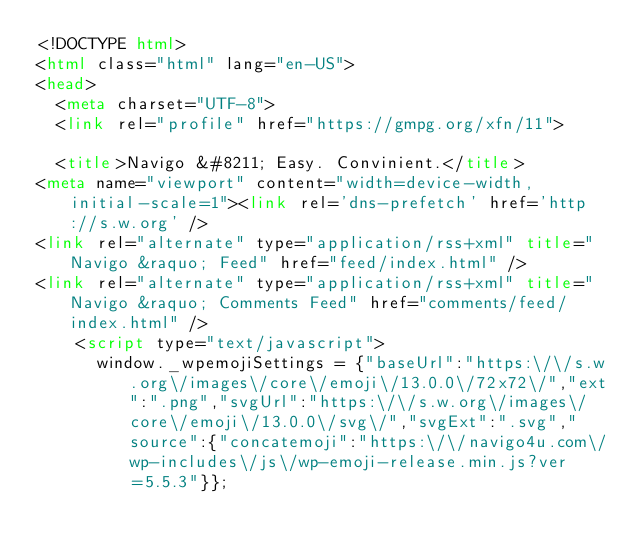Convert code to text. <code><loc_0><loc_0><loc_500><loc_500><_HTML_><!DOCTYPE html>
<html class="html" lang="en-US">
<head>
	<meta charset="UTF-8">
	<link rel="profile" href="https://gmpg.org/xfn/11">

	<title>Navigo &#8211; Easy. Convinient.</title>
<meta name="viewport" content="width=device-width, initial-scale=1"><link rel='dns-prefetch' href='http://s.w.org' />
<link rel="alternate" type="application/rss+xml" title="Navigo &raquo; Feed" href="feed/index.html" />
<link rel="alternate" type="application/rss+xml" title="Navigo &raquo; Comments Feed" href="comments/feed/index.html" />
		<script type="text/javascript">
			window._wpemojiSettings = {"baseUrl":"https:\/\/s.w.org\/images\/core\/emoji\/13.0.0\/72x72\/","ext":".png","svgUrl":"https:\/\/s.w.org\/images\/core\/emoji\/13.0.0\/svg\/","svgExt":".svg","source":{"concatemoji":"https:\/\/navigo4u.com\/wp-includes\/js\/wp-emoji-release.min.js?ver=5.5.3"}};</code> 